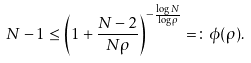Convert formula to latex. <formula><loc_0><loc_0><loc_500><loc_500>N - 1 \leq \left ( 1 + \frac { N - 2 } { N \rho } \right ) ^ { - \frac { \log N } { \log \rho } } = \colon \phi ( \rho ) .</formula> 